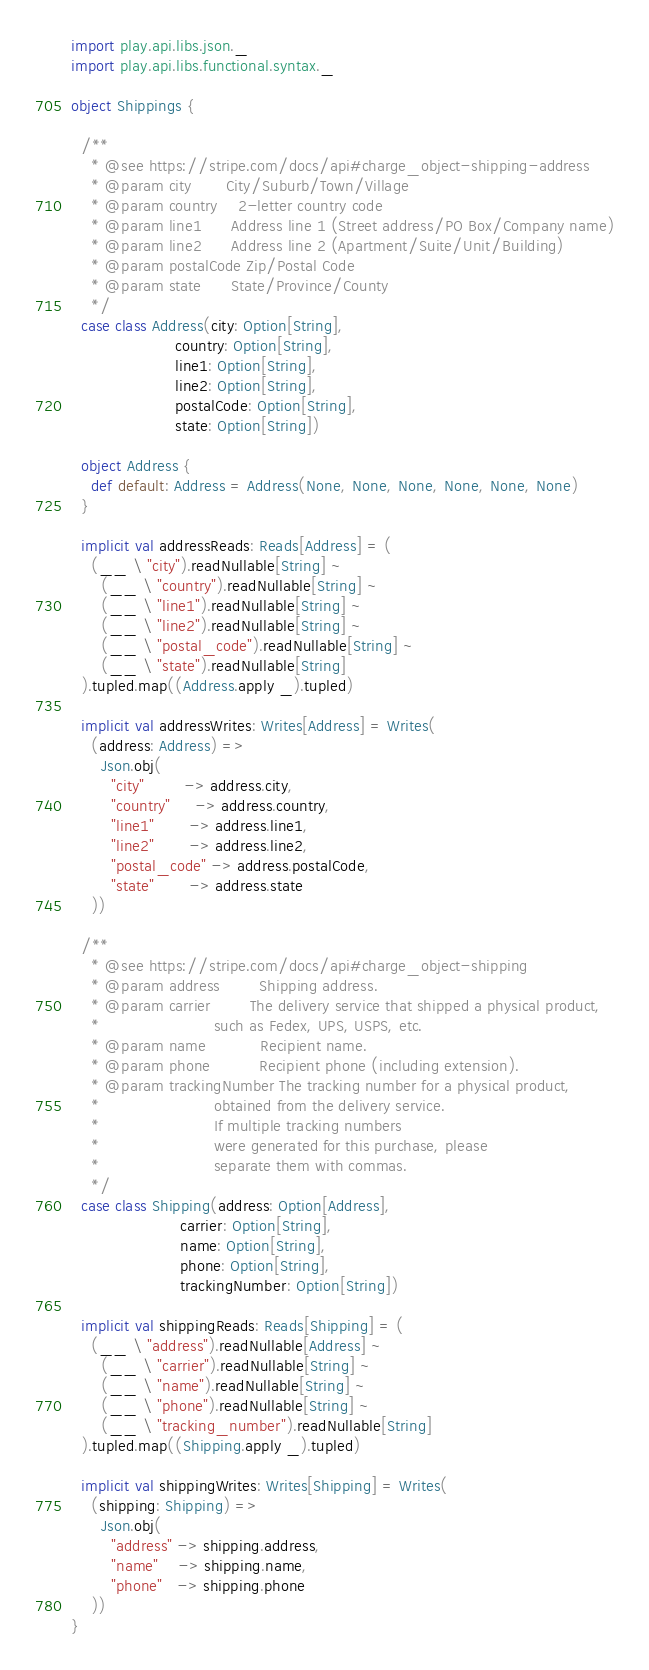Convert code to text. <code><loc_0><loc_0><loc_500><loc_500><_Scala_>import play.api.libs.json._
import play.api.libs.functional.syntax._

object Shippings {

  /**
    * @see https://stripe.com/docs/api#charge_object-shipping-address
    * @param city       City/Suburb/Town/Village
    * @param country    2-letter country code
    * @param line1      Address line 1 (Street address/PO Box/Company name)
    * @param line2      Address line 2 (Apartment/Suite/Unit/Building)
    * @param postalCode Zip/Postal Code
    * @param state      State/Province/County
    */
  case class Address(city: Option[String],
                     country: Option[String],
                     line1: Option[String],
                     line2: Option[String],
                     postalCode: Option[String],
                     state: Option[String])

  object Address {
    def default: Address = Address(None, None, None, None, None, None)
  }

  implicit val addressReads: Reads[Address] = (
    (__ \ "city").readNullable[String] ~
      (__ \ "country").readNullable[String] ~
      (__ \ "line1").readNullable[String] ~
      (__ \ "line2").readNullable[String] ~
      (__ \ "postal_code").readNullable[String] ~
      (__ \ "state").readNullable[String]
  ).tupled.map((Address.apply _).tupled)

  implicit val addressWrites: Writes[Address] = Writes(
    (address: Address) =>
      Json.obj(
        "city"        -> address.city,
        "country"     -> address.country,
        "line1"       -> address.line1,
        "line2"       -> address.line2,
        "postal_code" -> address.postalCode,
        "state"       -> address.state
    ))

  /**
    * @see https://stripe.com/docs/api#charge_object-shipping
    * @param address        Shipping address.
    * @param carrier        The delivery service that shipped a physical product,
    *                       such as Fedex, UPS, USPS, etc.
    * @param name           Recipient name.
    * @param phone          Recipient phone (including extension).
    * @param trackingNumber The tracking number for a physical product,
    *                       obtained from the delivery service.
    *                       If multiple tracking numbers
    *                       were generated for this purchase, please
    *                       separate them with commas.
    */
  case class Shipping(address: Option[Address],
                      carrier: Option[String],
                      name: Option[String],
                      phone: Option[String],
                      trackingNumber: Option[String])

  implicit val shippingReads: Reads[Shipping] = (
    (__ \ "address").readNullable[Address] ~
      (__ \ "carrier").readNullable[String] ~
      (__ \ "name").readNullable[String] ~
      (__ \ "phone").readNullable[String] ~
      (__ \ "tracking_number").readNullable[String]
  ).tupled.map((Shipping.apply _).tupled)

  implicit val shippingWrites: Writes[Shipping] = Writes(
    (shipping: Shipping) =>
      Json.obj(
        "address" -> shipping.address,
        "name"    -> shipping.name,
        "phone"   -> shipping.phone
    ))
}
</code> 